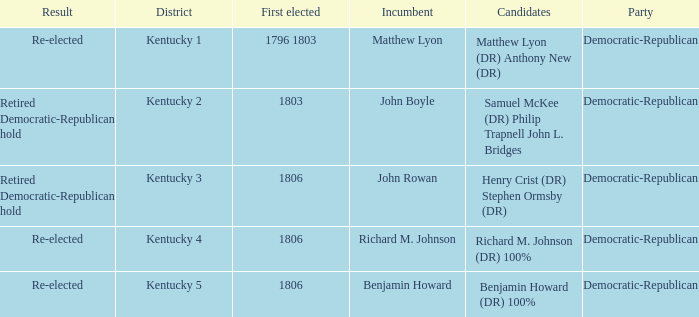Name the number of party for kentucky 1 1.0. 